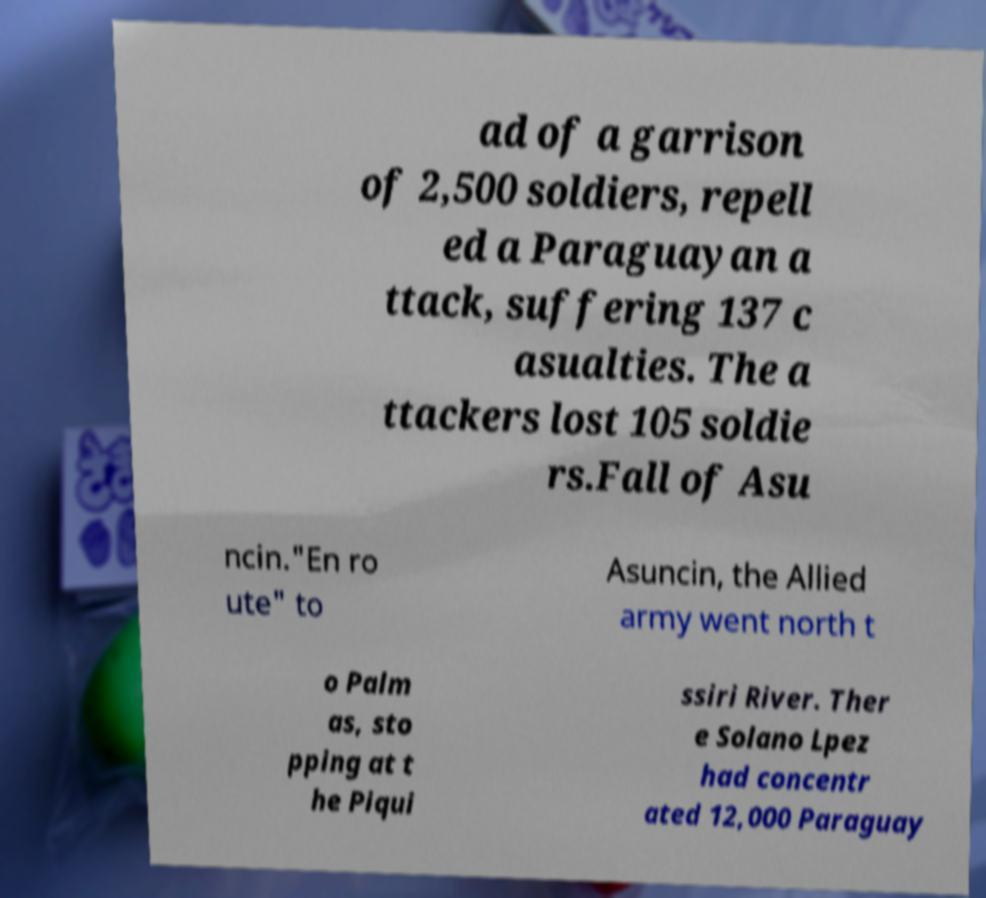Can you accurately transcribe the text from the provided image for me? ad of a garrison of 2,500 soldiers, repell ed a Paraguayan a ttack, suffering 137 c asualties. The a ttackers lost 105 soldie rs.Fall of Asu ncin."En ro ute" to Asuncin, the Allied army went north t o Palm as, sto pping at t he Piqui ssiri River. Ther e Solano Lpez had concentr ated 12,000 Paraguay 